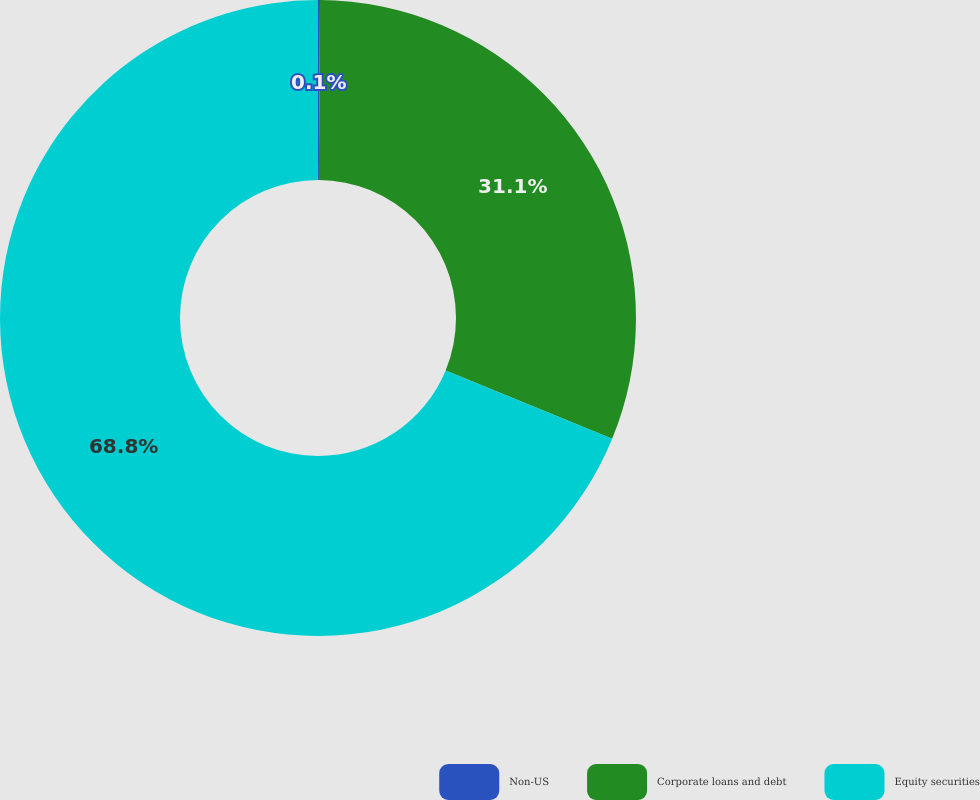Convert chart. <chart><loc_0><loc_0><loc_500><loc_500><pie_chart><fcel>Non-US<fcel>Corporate loans and debt<fcel>Equity securities<nl><fcel>0.1%<fcel>31.1%<fcel>68.8%<nl></chart> 